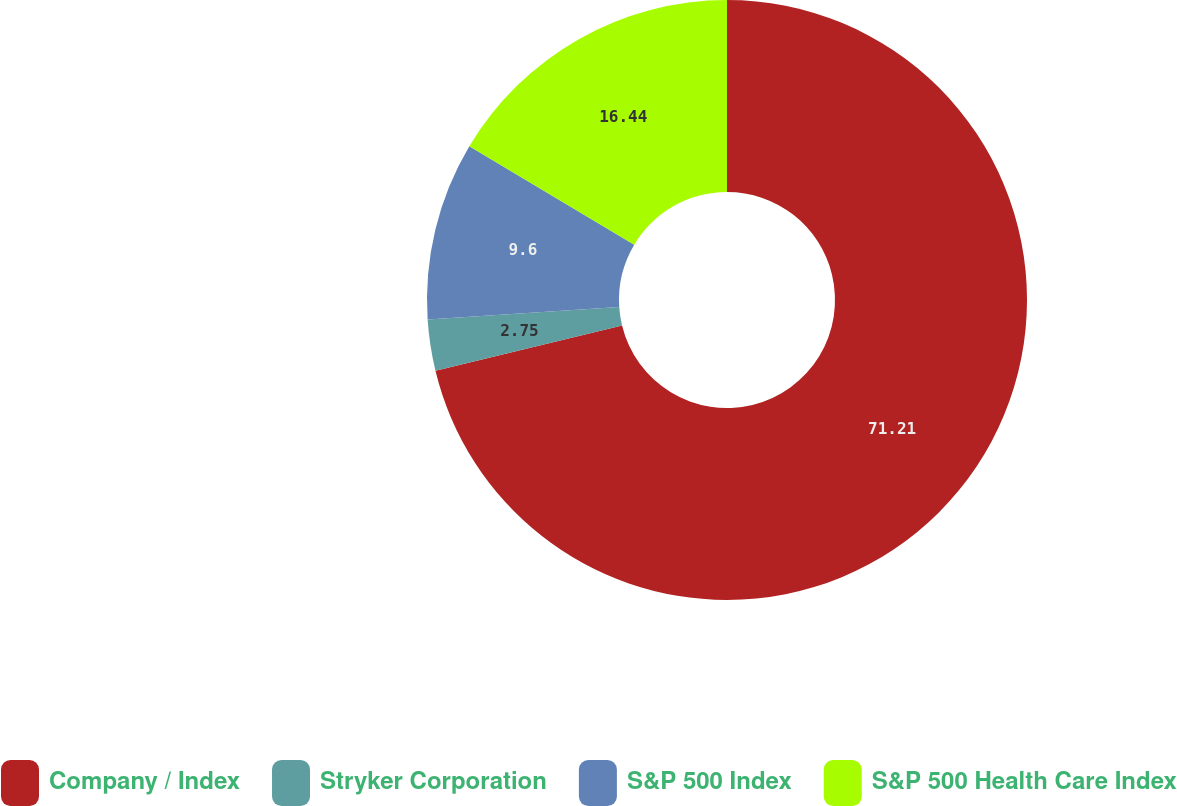<chart> <loc_0><loc_0><loc_500><loc_500><pie_chart><fcel>Company / Index<fcel>Stryker Corporation<fcel>S&P 500 Index<fcel>S&P 500 Health Care Index<nl><fcel>71.21%<fcel>2.75%<fcel>9.6%<fcel>16.44%<nl></chart> 